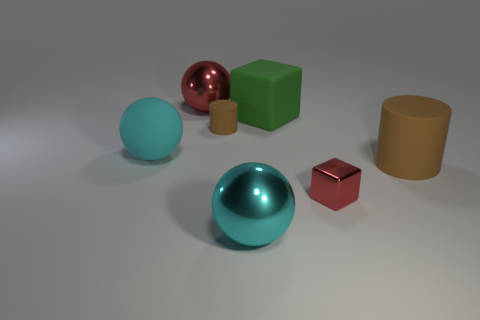There is a tiny cylinder that is the same color as the large cylinder; what material is it? If we assume that objects of the same color in this image are made of the same material, then the tiny cylinder, sharing the same hue as the large cylinder, would likely be made of a matte-finished plastic. 